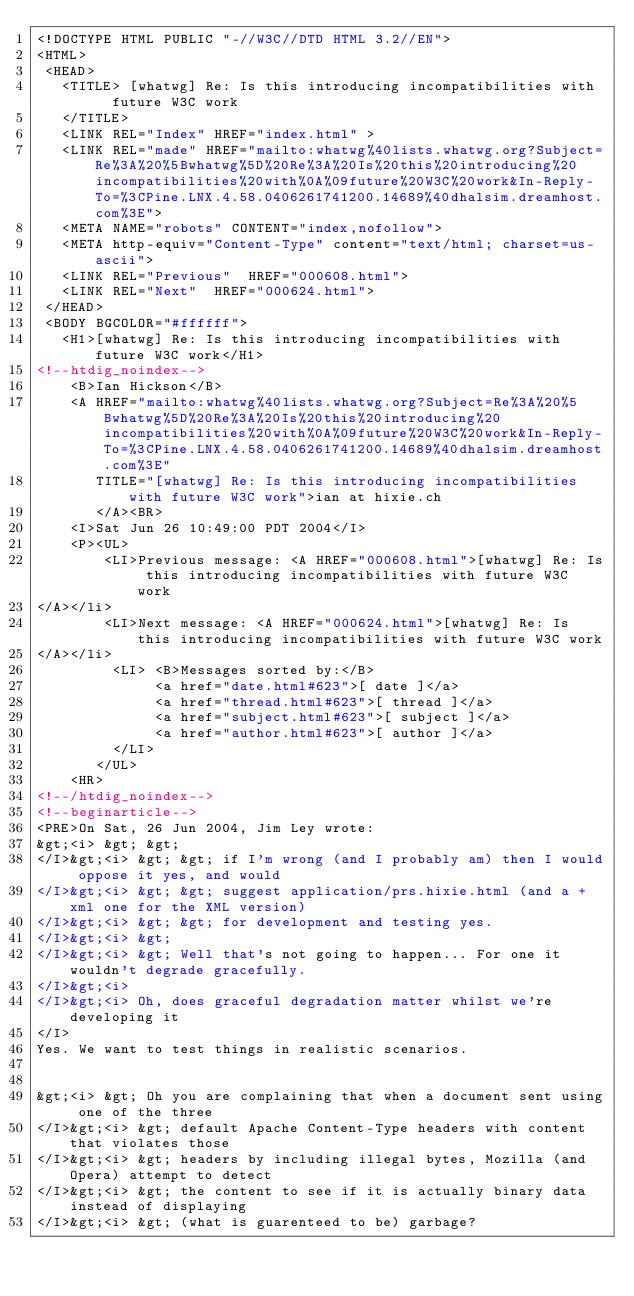<code> <loc_0><loc_0><loc_500><loc_500><_HTML_><!DOCTYPE HTML PUBLIC "-//W3C//DTD HTML 3.2//EN">
<HTML>
 <HEAD>
   <TITLE> [whatwg] Re: Is this introducing incompatibilities with	future W3C work
   </TITLE>
   <LINK REL="Index" HREF="index.html" >
   <LINK REL="made" HREF="mailto:whatwg%40lists.whatwg.org?Subject=Re%3A%20%5Bwhatwg%5D%20Re%3A%20Is%20this%20introducing%20incompatibilities%20with%0A%09future%20W3C%20work&In-Reply-To=%3CPine.LNX.4.58.0406261741200.14689%40dhalsim.dreamhost.com%3E">
   <META NAME="robots" CONTENT="index,nofollow">
   <META http-equiv="Content-Type" content="text/html; charset=us-ascii">
   <LINK REL="Previous"  HREF="000608.html">
   <LINK REL="Next"  HREF="000624.html">
 </HEAD>
 <BODY BGCOLOR="#ffffff">
   <H1>[whatwg] Re: Is this introducing incompatibilities with	future W3C work</H1>
<!--htdig_noindex-->
    <B>Ian Hickson</B> 
    <A HREF="mailto:whatwg%40lists.whatwg.org?Subject=Re%3A%20%5Bwhatwg%5D%20Re%3A%20Is%20this%20introducing%20incompatibilities%20with%0A%09future%20W3C%20work&In-Reply-To=%3CPine.LNX.4.58.0406261741200.14689%40dhalsim.dreamhost.com%3E"
       TITLE="[whatwg] Re: Is this introducing incompatibilities with	future W3C work">ian at hixie.ch
       </A><BR>
    <I>Sat Jun 26 10:49:00 PDT 2004</I>
    <P><UL>
        <LI>Previous message: <A HREF="000608.html">[whatwg] Re: Is this introducing incompatibilities with	future W3C work
</A></li>
        <LI>Next message: <A HREF="000624.html">[whatwg] Re: Is this introducing incompatibilities with	future W3C work
</A></li>
         <LI> <B>Messages sorted by:</B> 
              <a href="date.html#623">[ date ]</a>
              <a href="thread.html#623">[ thread ]</a>
              <a href="subject.html#623">[ subject ]</a>
              <a href="author.html#623">[ author ]</a>
         </LI>
       </UL>
    <HR>  
<!--/htdig_noindex-->
<!--beginarticle-->
<PRE>On Sat, 26 Jun 2004, Jim Ley wrote:
&gt;<i> &gt; &gt;
</I>&gt;<i> &gt; &gt; if I'm wrong (and I probably am) then I would oppose it yes, and would
</I>&gt;<i> &gt; &gt; suggest application/prs.hixie.html (and a +xml one for the XML version)
</I>&gt;<i> &gt; &gt; for development and testing yes.
</I>&gt;<i> &gt;
</I>&gt;<i> &gt; Well that's not going to happen... For one it wouldn't degrade gracefully.
</I>&gt;<i>
</I>&gt;<i> Oh, does graceful degradation matter whilst we're developing it
</I>
Yes. We want to test things in realistic scenarios.


&gt;<i> &gt; Oh you are complaining that when a document sent using one of the three
</I>&gt;<i> &gt; default Apache Content-Type headers with content that violates those
</I>&gt;<i> &gt; headers by including illegal bytes, Mozilla (and Opera) attempt to detect
</I>&gt;<i> &gt; the content to see if it is actually binary data instead of displaying
</I>&gt;<i> &gt; (what is guarenteed to be) garbage?</code> 